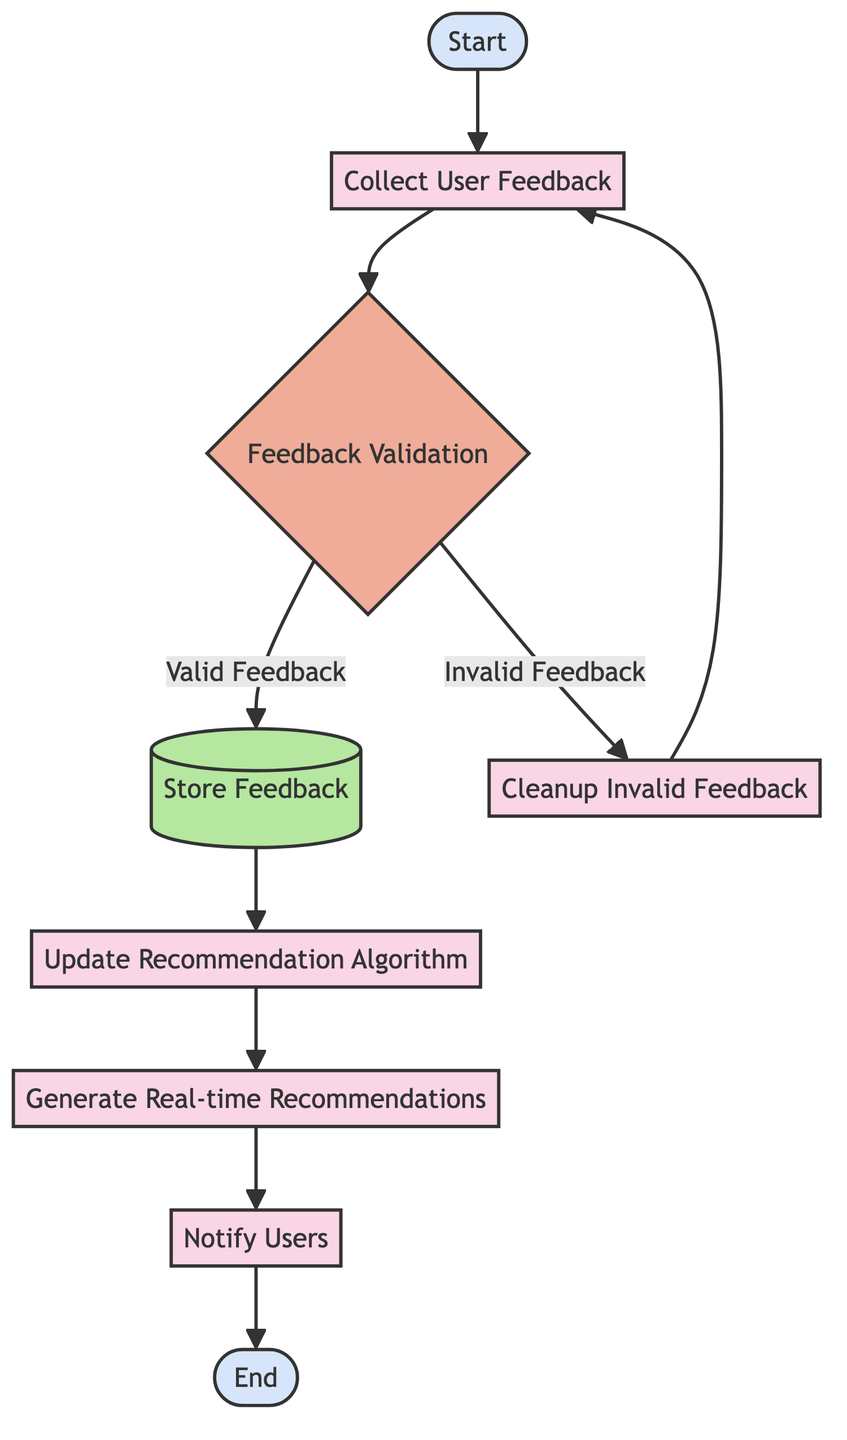What is the first action in the flow chart? The flow chart begins with the "Start" event, indicating the initiation of the process.
Answer: Start How many decision points are in this flow chart? There is one decision point called "Feedback Validation," which determines the authenticity and quality of feedback.
Answer: 1 What happens to valid feedback? Valid feedback is stored in the data repository after passing the feedback validation check.
Answer: Store Feedback What is done with invalid feedback? Invalid feedback is filtered out, which includes cleaning up spam and inappropriate content, and then the process loops back to collecting user feedback.
Answer: Cleanup Invalid Feedback What is the last action before the "End" event? The last action before reaching the "End" event is "Notify Users," where users are informed about updated recommendations based on the feedback processed.
Answer: Notify Users In which step is the recommendation algorithm updated? The recommendation algorithm is updated in the step following the storage of valid feedback, specifically in the "Update Recommendation Algorithm" process.
Answer: Update Recommendation Algorithm How does the flow proceed if the feedback is invalid? If the feedback is invalid, the process filters out the inappropriate content and then loops back to the "Collect User Feedback" step, starting the process over.
Answer: Collect User Feedback What type of node is "Generate Real-time Recommendations"? "Generate Real-time Recommendations" is categorized as a process node, as it represents an action that produces updated recommendations for users.
Answer: Process Which element represents the storage of feedback? The storage of valid feedback is represented by the "Store Feedback" node, which is a database type node in the diagram.
Answer: Store Feedback What is the purpose of the "Notify Users" step? The purpose of the "Notify Users" step is to inform users of the changes in recommendations that have occurred due to the newly processed user feedback.
Answer: Inform users 